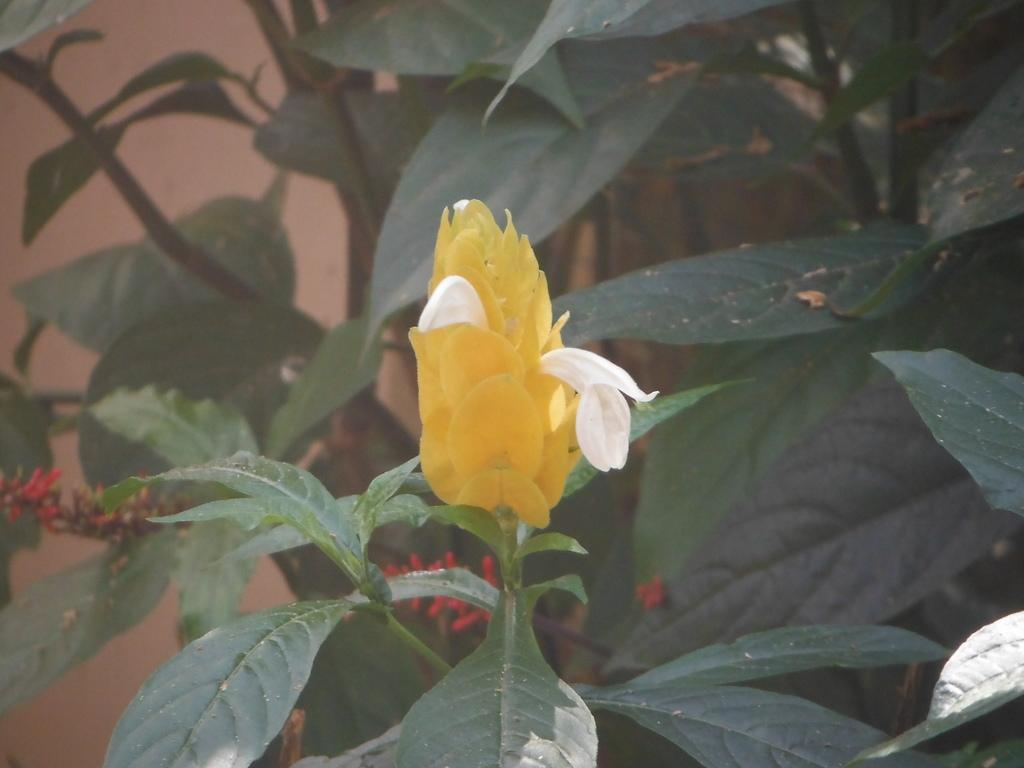What type of living organism is present in the image? There is a plant in the image. What are the main features of the plant? The plant has leaves and a flower. Are there any specific details about the plant's appearance? Yes, there are red color buds on the plant. What type of pies can be seen baking in the image? There are no pies present in the image; it features a plant with leaves, a flower, and red color buds. 